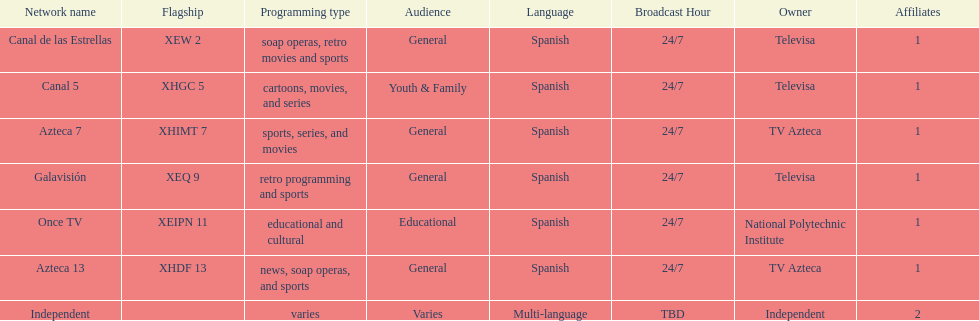How many affiliates does galavision have? 1. 